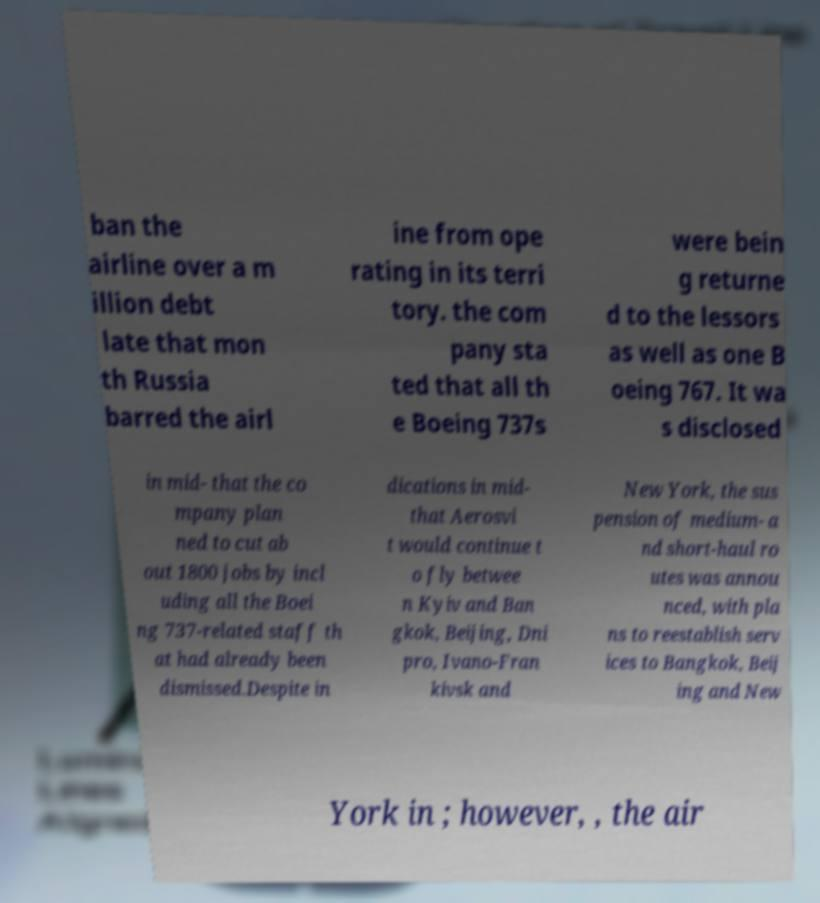Can you read and provide the text displayed in the image?This photo seems to have some interesting text. Can you extract and type it out for me? ban the airline over a m illion debt late that mon th Russia barred the airl ine from ope rating in its terri tory. the com pany sta ted that all th e Boeing 737s were bein g returne d to the lessors as well as one B oeing 767. It wa s disclosed in mid- that the co mpany plan ned to cut ab out 1800 jobs by incl uding all the Boei ng 737-related staff th at had already been dismissed.Despite in dications in mid- that Aerosvi t would continue t o fly betwee n Kyiv and Ban gkok, Beijing, Dni pro, Ivano-Fran kivsk and New York, the sus pension of medium- a nd short-haul ro utes was annou nced, with pla ns to reestablish serv ices to Bangkok, Beij ing and New York in ; however, , the air 